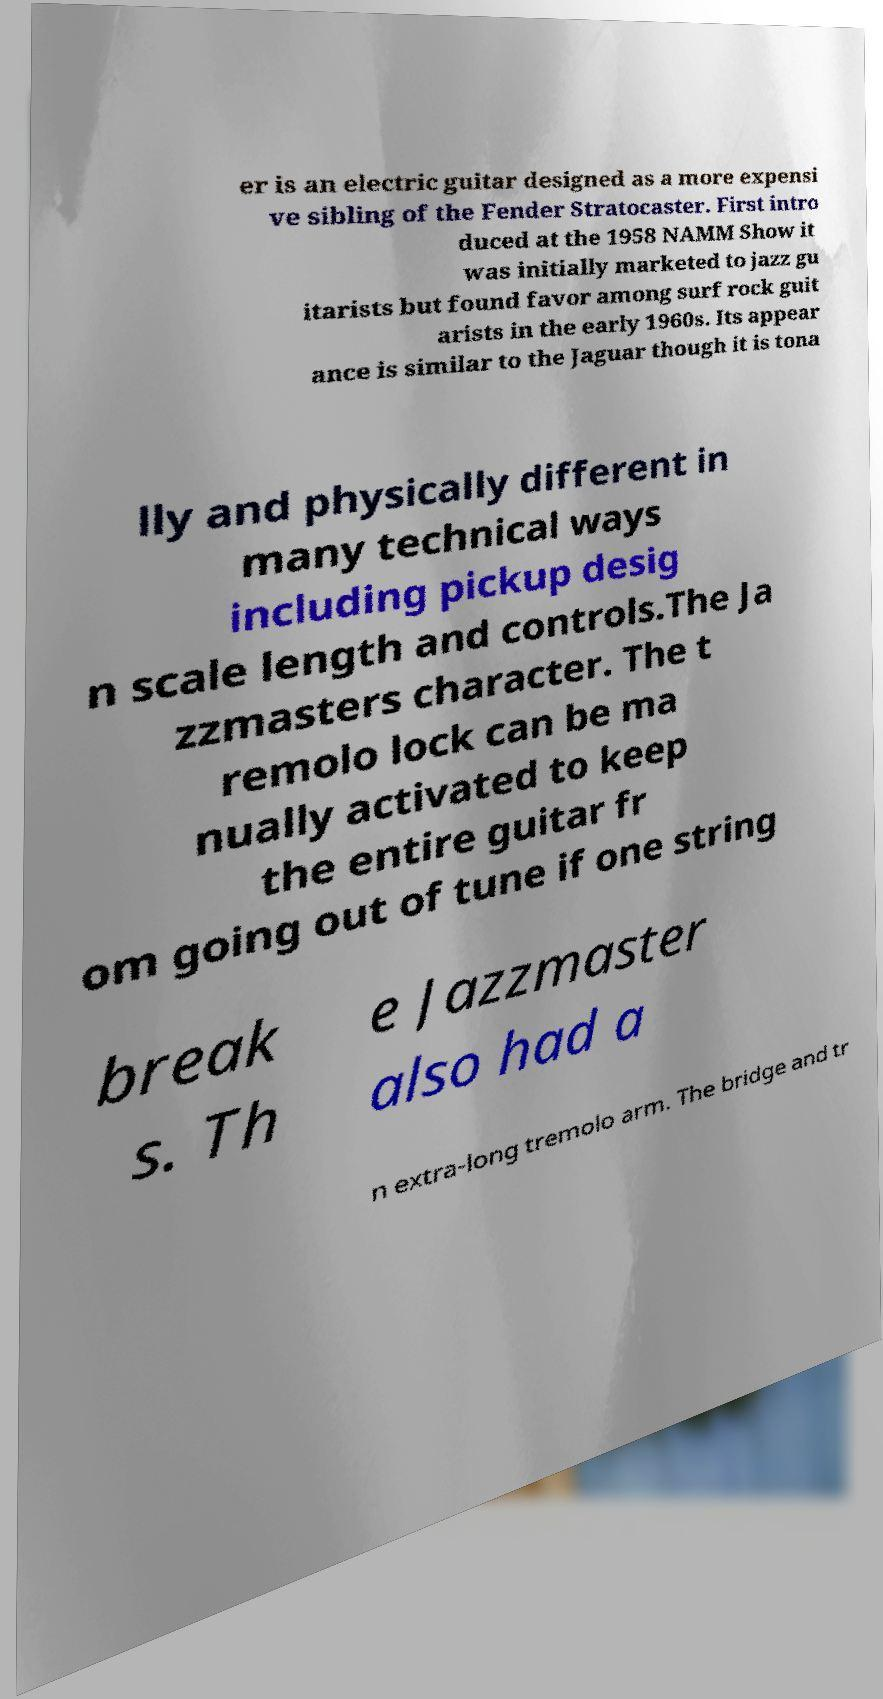There's text embedded in this image that I need extracted. Can you transcribe it verbatim? er is an electric guitar designed as a more expensi ve sibling of the Fender Stratocaster. First intro duced at the 1958 NAMM Show it was initially marketed to jazz gu itarists but found favor among surf rock guit arists in the early 1960s. Its appear ance is similar to the Jaguar though it is tona lly and physically different in many technical ways including pickup desig n scale length and controls.The Ja zzmasters character. The t remolo lock can be ma nually activated to keep the entire guitar fr om going out of tune if one string break s. Th e Jazzmaster also had a n extra-long tremolo arm. The bridge and tr 